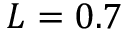<formula> <loc_0><loc_0><loc_500><loc_500>L = 0 . 7</formula> 